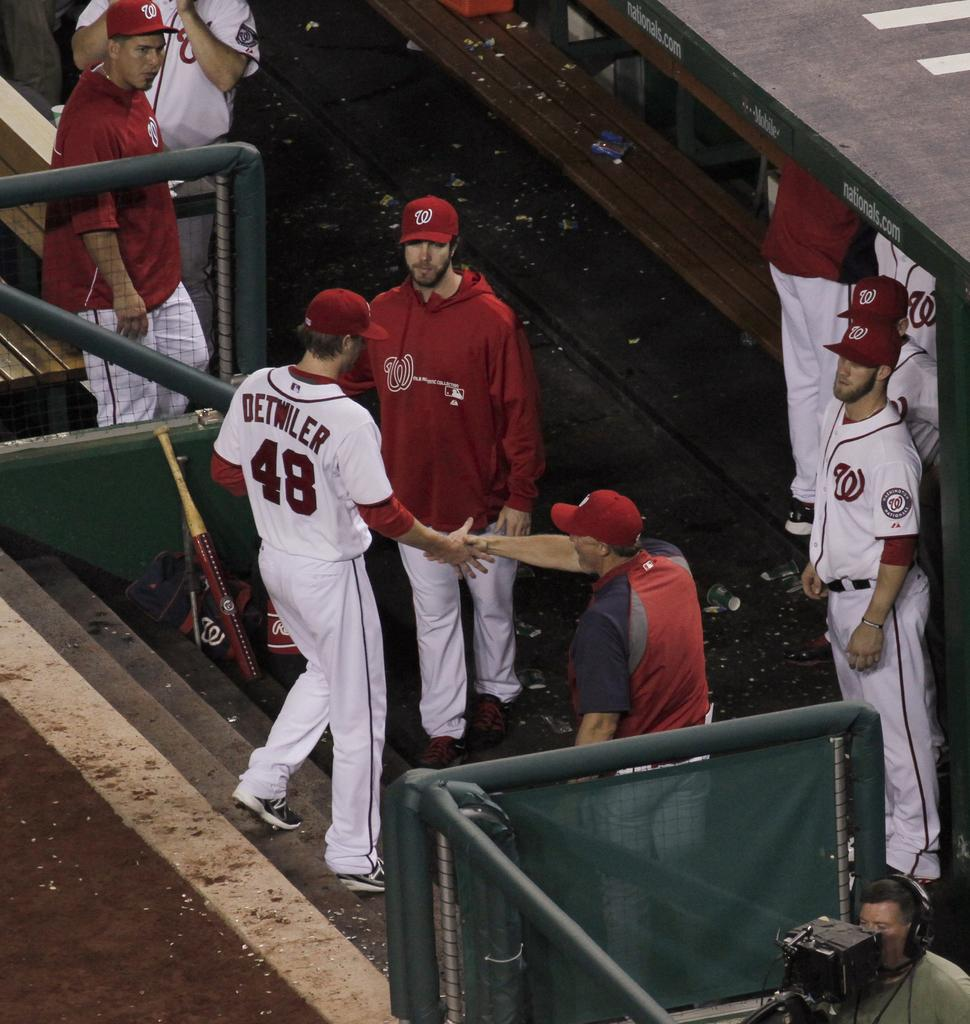<image>
Provide a brief description of the given image. Detwiler is shaking hands with a man in a red hat as he walks down the stairs 